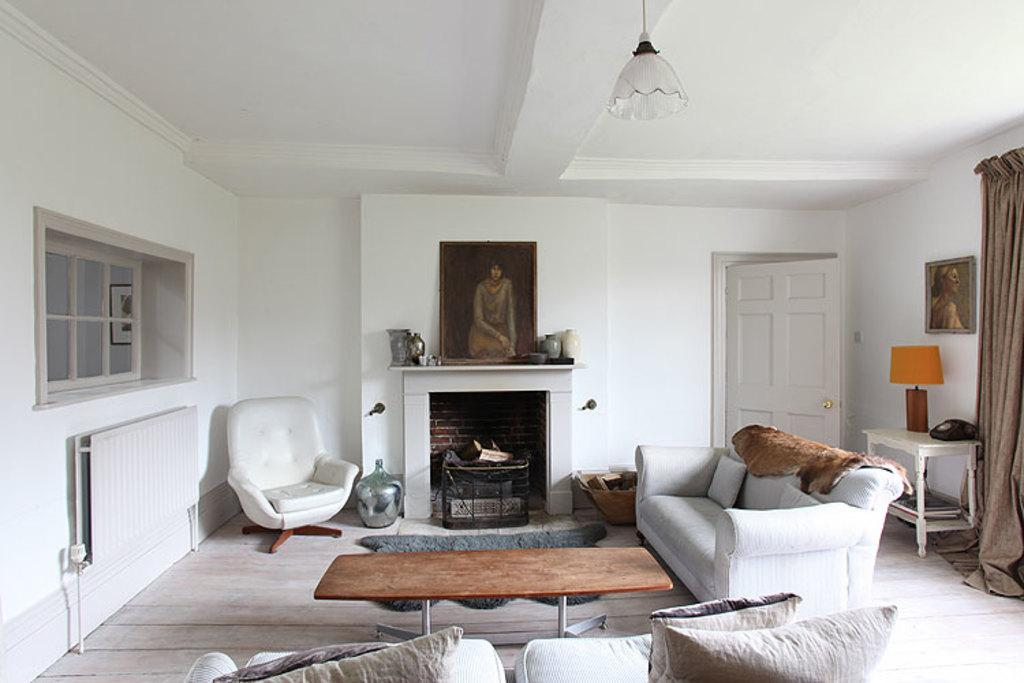How many sofas are in the image? There are two sofas in the image. What color is the table in the image? The table in the image is brown. What type of appliance is present in the image? A room heater is present in the image. What type of windows are in the image? There are glass windows in the image. What type of lighting is visible in the image? A lamp is visible in the image. What type of communication device is present in the image? A telephone is present in the image. What type of decorative items are in the image? There are photo frames in the image. What type of glass object is in the image? There is a glass amenity in the image. Where is the scene of the image located? The scene is inside a house. What nation is represented by the writing on the wall in the image? There is no writing on the wall in the image, so it is not possible to determine which nation might be represented. 